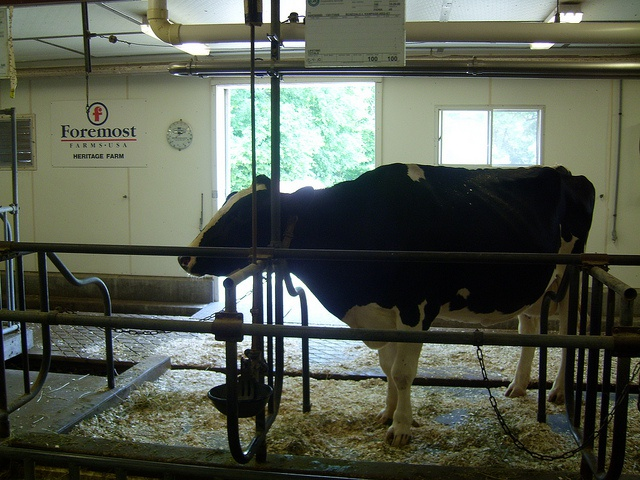Describe the objects in this image and their specific colors. I can see cow in black, darkgreen, and gray tones and clock in black, gray, and darkgray tones in this image. 